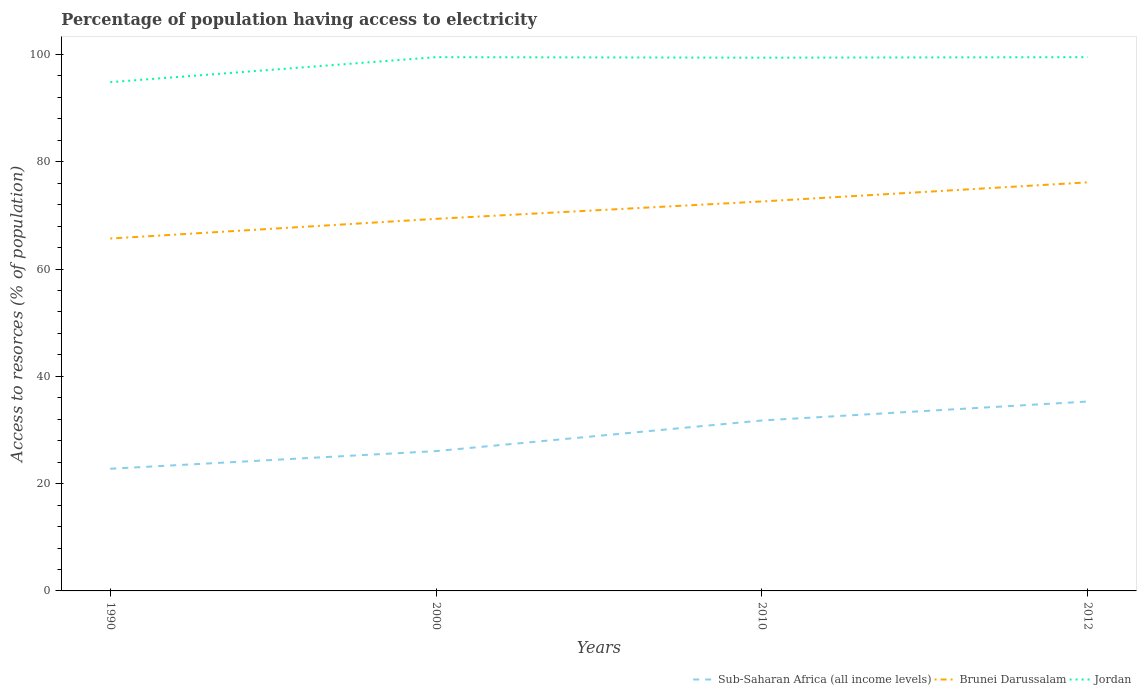Does the line corresponding to Brunei Darussalam intersect with the line corresponding to Sub-Saharan Africa (all income levels)?
Make the answer very short. No. Across all years, what is the maximum percentage of population having access to electricity in Sub-Saharan Africa (all income levels)?
Make the answer very short. 22.77. What is the total percentage of population having access to electricity in Jordan in the graph?
Offer a very short reply. -4.66. What is the difference between the highest and the second highest percentage of population having access to electricity in Brunei Darussalam?
Offer a terse response. 10.47. What is the difference between the highest and the lowest percentage of population having access to electricity in Sub-Saharan Africa (all income levels)?
Your response must be concise. 2. How many years are there in the graph?
Ensure brevity in your answer.  4. What is the difference between two consecutive major ticks on the Y-axis?
Offer a very short reply. 20. Are the values on the major ticks of Y-axis written in scientific E-notation?
Your answer should be compact. No. Does the graph contain any zero values?
Provide a succinct answer. No. Where does the legend appear in the graph?
Offer a terse response. Bottom right. How are the legend labels stacked?
Your answer should be very brief. Horizontal. What is the title of the graph?
Give a very brief answer. Percentage of population having access to electricity. Does "Afghanistan" appear as one of the legend labels in the graph?
Ensure brevity in your answer.  No. What is the label or title of the X-axis?
Your answer should be compact. Years. What is the label or title of the Y-axis?
Keep it short and to the point. Access to resorces (% of population). What is the Access to resorces (% of population) in Sub-Saharan Africa (all income levels) in 1990?
Offer a terse response. 22.77. What is the Access to resorces (% of population) of Brunei Darussalam in 1990?
Offer a terse response. 65.69. What is the Access to resorces (% of population) in Jordan in 1990?
Provide a succinct answer. 94.84. What is the Access to resorces (% of population) in Sub-Saharan Africa (all income levels) in 2000?
Make the answer very short. 26.06. What is the Access to resorces (% of population) in Brunei Darussalam in 2000?
Offer a very short reply. 69.36. What is the Access to resorces (% of population) in Jordan in 2000?
Your answer should be very brief. 99.5. What is the Access to resorces (% of population) in Sub-Saharan Africa (all income levels) in 2010?
Offer a terse response. 31.77. What is the Access to resorces (% of population) in Brunei Darussalam in 2010?
Make the answer very short. 72.6. What is the Access to resorces (% of population) of Jordan in 2010?
Make the answer very short. 99.4. What is the Access to resorces (% of population) in Sub-Saharan Africa (all income levels) in 2012?
Provide a succinct answer. 35.31. What is the Access to resorces (% of population) in Brunei Darussalam in 2012?
Offer a very short reply. 76.16. What is the Access to resorces (% of population) in Jordan in 2012?
Offer a terse response. 99.5. Across all years, what is the maximum Access to resorces (% of population) in Sub-Saharan Africa (all income levels)?
Offer a very short reply. 35.31. Across all years, what is the maximum Access to resorces (% of population) of Brunei Darussalam?
Provide a short and direct response. 76.16. Across all years, what is the maximum Access to resorces (% of population) of Jordan?
Make the answer very short. 99.5. Across all years, what is the minimum Access to resorces (% of population) of Sub-Saharan Africa (all income levels)?
Provide a short and direct response. 22.77. Across all years, what is the minimum Access to resorces (% of population) of Brunei Darussalam?
Your answer should be very brief. 65.69. Across all years, what is the minimum Access to resorces (% of population) of Jordan?
Ensure brevity in your answer.  94.84. What is the total Access to resorces (% of population) in Sub-Saharan Africa (all income levels) in the graph?
Provide a succinct answer. 115.92. What is the total Access to resorces (% of population) of Brunei Darussalam in the graph?
Your response must be concise. 283.82. What is the total Access to resorces (% of population) in Jordan in the graph?
Your answer should be very brief. 393.24. What is the difference between the Access to resorces (% of population) in Sub-Saharan Africa (all income levels) in 1990 and that in 2000?
Provide a succinct answer. -3.29. What is the difference between the Access to resorces (% of population) of Brunei Darussalam in 1990 and that in 2000?
Your response must be concise. -3.67. What is the difference between the Access to resorces (% of population) in Jordan in 1990 and that in 2000?
Keep it short and to the point. -4.66. What is the difference between the Access to resorces (% of population) of Sub-Saharan Africa (all income levels) in 1990 and that in 2010?
Your response must be concise. -9. What is the difference between the Access to resorces (% of population) of Brunei Darussalam in 1990 and that in 2010?
Ensure brevity in your answer.  -6.91. What is the difference between the Access to resorces (% of population) in Jordan in 1990 and that in 2010?
Provide a succinct answer. -4.56. What is the difference between the Access to resorces (% of population) in Sub-Saharan Africa (all income levels) in 1990 and that in 2012?
Your answer should be very brief. -12.53. What is the difference between the Access to resorces (% of population) of Brunei Darussalam in 1990 and that in 2012?
Your answer should be very brief. -10.47. What is the difference between the Access to resorces (% of population) of Jordan in 1990 and that in 2012?
Your response must be concise. -4.66. What is the difference between the Access to resorces (% of population) of Sub-Saharan Africa (all income levels) in 2000 and that in 2010?
Keep it short and to the point. -5.71. What is the difference between the Access to resorces (% of population) of Brunei Darussalam in 2000 and that in 2010?
Provide a short and direct response. -3.24. What is the difference between the Access to resorces (% of population) in Jordan in 2000 and that in 2010?
Offer a very short reply. 0.1. What is the difference between the Access to resorces (% of population) of Sub-Saharan Africa (all income levels) in 2000 and that in 2012?
Ensure brevity in your answer.  -9.24. What is the difference between the Access to resorces (% of population) of Brunei Darussalam in 2000 and that in 2012?
Your response must be concise. -6.8. What is the difference between the Access to resorces (% of population) of Sub-Saharan Africa (all income levels) in 2010 and that in 2012?
Provide a short and direct response. -3.53. What is the difference between the Access to resorces (% of population) in Brunei Darussalam in 2010 and that in 2012?
Keep it short and to the point. -3.56. What is the difference between the Access to resorces (% of population) in Jordan in 2010 and that in 2012?
Offer a very short reply. -0.1. What is the difference between the Access to resorces (% of population) of Sub-Saharan Africa (all income levels) in 1990 and the Access to resorces (% of population) of Brunei Darussalam in 2000?
Keep it short and to the point. -46.59. What is the difference between the Access to resorces (% of population) in Sub-Saharan Africa (all income levels) in 1990 and the Access to resorces (% of population) in Jordan in 2000?
Your response must be concise. -76.73. What is the difference between the Access to resorces (% of population) of Brunei Darussalam in 1990 and the Access to resorces (% of population) of Jordan in 2000?
Provide a succinct answer. -33.81. What is the difference between the Access to resorces (% of population) in Sub-Saharan Africa (all income levels) in 1990 and the Access to resorces (% of population) in Brunei Darussalam in 2010?
Give a very brief answer. -49.83. What is the difference between the Access to resorces (% of population) of Sub-Saharan Africa (all income levels) in 1990 and the Access to resorces (% of population) of Jordan in 2010?
Your response must be concise. -76.63. What is the difference between the Access to resorces (% of population) of Brunei Darussalam in 1990 and the Access to resorces (% of population) of Jordan in 2010?
Your answer should be very brief. -33.71. What is the difference between the Access to resorces (% of population) in Sub-Saharan Africa (all income levels) in 1990 and the Access to resorces (% of population) in Brunei Darussalam in 2012?
Keep it short and to the point. -53.39. What is the difference between the Access to resorces (% of population) in Sub-Saharan Africa (all income levels) in 1990 and the Access to resorces (% of population) in Jordan in 2012?
Give a very brief answer. -76.73. What is the difference between the Access to resorces (% of population) of Brunei Darussalam in 1990 and the Access to resorces (% of population) of Jordan in 2012?
Your answer should be compact. -33.81. What is the difference between the Access to resorces (% of population) of Sub-Saharan Africa (all income levels) in 2000 and the Access to resorces (% of population) of Brunei Darussalam in 2010?
Provide a short and direct response. -46.54. What is the difference between the Access to resorces (% of population) of Sub-Saharan Africa (all income levels) in 2000 and the Access to resorces (% of population) of Jordan in 2010?
Keep it short and to the point. -73.34. What is the difference between the Access to resorces (% of population) in Brunei Darussalam in 2000 and the Access to resorces (% of population) in Jordan in 2010?
Make the answer very short. -30.04. What is the difference between the Access to resorces (% of population) in Sub-Saharan Africa (all income levels) in 2000 and the Access to resorces (% of population) in Brunei Darussalam in 2012?
Your answer should be very brief. -50.1. What is the difference between the Access to resorces (% of population) in Sub-Saharan Africa (all income levels) in 2000 and the Access to resorces (% of population) in Jordan in 2012?
Provide a succinct answer. -73.44. What is the difference between the Access to resorces (% of population) of Brunei Darussalam in 2000 and the Access to resorces (% of population) of Jordan in 2012?
Give a very brief answer. -30.14. What is the difference between the Access to resorces (% of population) in Sub-Saharan Africa (all income levels) in 2010 and the Access to resorces (% of population) in Brunei Darussalam in 2012?
Your response must be concise. -44.39. What is the difference between the Access to resorces (% of population) in Sub-Saharan Africa (all income levels) in 2010 and the Access to resorces (% of population) in Jordan in 2012?
Ensure brevity in your answer.  -67.73. What is the difference between the Access to resorces (% of population) of Brunei Darussalam in 2010 and the Access to resorces (% of population) of Jordan in 2012?
Give a very brief answer. -26.9. What is the average Access to resorces (% of population) in Sub-Saharan Africa (all income levels) per year?
Give a very brief answer. 28.98. What is the average Access to resorces (% of population) of Brunei Darussalam per year?
Make the answer very short. 70.95. What is the average Access to resorces (% of population) of Jordan per year?
Keep it short and to the point. 98.31. In the year 1990, what is the difference between the Access to resorces (% of population) in Sub-Saharan Africa (all income levels) and Access to resorces (% of population) in Brunei Darussalam?
Keep it short and to the point. -42.92. In the year 1990, what is the difference between the Access to resorces (% of population) in Sub-Saharan Africa (all income levels) and Access to resorces (% of population) in Jordan?
Keep it short and to the point. -72.07. In the year 1990, what is the difference between the Access to resorces (% of population) in Brunei Darussalam and Access to resorces (% of population) in Jordan?
Give a very brief answer. -29.15. In the year 2000, what is the difference between the Access to resorces (% of population) of Sub-Saharan Africa (all income levels) and Access to resorces (% of population) of Brunei Darussalam?
Make the answer very short. -43.3. In the year 2000, what is the difference between the Access to resorces (% of population) of Sub-Saharan Africa (all income levels) and Access to resorces (% of population) of Jordan?
Make the answer very short. -73.44. In the year 2000, what is the difference between the Access to resorces (% of population) in Brunei Darussalam and Access to resorces (% of population) in Jordan?
Offer a terse response. -30.14. In the year 2010, what is the difference between the Access to resorces (% of population) in Sub-Saharan Africa (all income levels) and Access to resorces (% of population) in Brunei Darussalam?
Your response must be concise. -40.83. In the year 2010, what is the difference between the Access to resorces (% of population) in Sub-Saharan Africa (all income levels) and Access to resorces (% of population) in Jordan?
Offer a very short reply. -67.63. In the year 2010, what is the difference between the Access to resorces (% of population) of Brunei Darussalam and Access to resorces (% of population) of Jordan?
Keep it short and to the point. -26.8. In the year 2012, what is the difference between the Access to resorces (% of population) of Sub-Saharan Africa (all income levels) and Access to resorces (% of population) of Brunei Darussalam?
Offer a terse response. -40.86. In the year 2012, what is the difference between the Access to resorces (% of population) in Sub-Saharan Africa (all income levels) and Access to resorces (% of population) in Jordan?
Provide a short and direct response. -64.19. In the year 2012, what is the difference between the Access to resorces (% of population) in Brunei Darussalam and Access to resorces (% of population) in Jordan?
Provide a short and direct response. -23.34. What is the ratio of the Access to resorces (% of population) in Sub-Saharan Africa (all income levels) in 1990 to that in 2000?
Provide a short and direct response. 0.87. What is the ratio of the Access to resorces (% of population) of Brunei Darussalam in 1990 to that in 2000?
Make the answer very short. 0.95. What is the ratio of the Access to resorces (% of population) of Jordan in 1990 to that in 2000?
Give a very brief answer. 0.95. What is the ratio of the Access to resorces (% of population) of Sub-Saharan Africa (all income levels) in 1990 to that in 2010?
Make the answer very short. 0.72. What is the ratio of the Access to resorces (% of population) in Brunei Darussalam in 1990 to that in 2010?
Offer a terse response. 0.9. What is the ratio of the Access to resorces (% of population) in Jordan in 1990 to that in 2010?
Your answer should be compact. 0.95. What is the ratio of the Access to resorces (% of population) of Sub-Saharan Africa (all income levels) in 1990 to that in 2012?
Provide a succinct answer. 0.65. What is the ratio of the Access to resorces (% of population) of Brunei Darussalam in 1990 to that in 2012?
Make the answer very short. 0.86. What is the ratio of the Access to resorces (% of population) in Jordan in 1990 to that in 2012?
Offer a terse response. 0.95. What is the ratio of the Access to resorces (% of population) in Sub-Saharan Africa (all income levels) in 2000 to that in 2010?
Your answer should be compact. 0.82. What is the ratio of the Access to resorces (% of population) in Brunei Darussalam in 2000 to that in 2010?
Provide a succinct answer. 0.96. What is the ratio of the Access to resorces (% of population) of Jordan in 2000 to that in 2010?
Make the answer very short. 1. What is the ratio of the Access to resorces (% of population) of Sub-Saharan Africa (all income levels) in 2000 to that in 2012?
Keep it short and to the point. 0.74. What is the ratio of the Access to resorces (% of population) in Brunei Darussalam in 2000 to that in 2012?
Provide a short and direct response. 0.91. What is the ratio of the Access to resorces (% of population) in Jordan in 2000 to that in 2012?
Your answer should be compact. 1. What is the ratio of the Access to resorces (% of population) in Sub-Saharan Africa (all income levels) in 2010 to that in 2012?
Give a very brief answer. 0.9. What is the ratio of the Access to resorces (% of population) in Brunei Darussalam in 2010 to that in 2012?
Keep it short and to the point. 0.95. What is the ratio of the Access to resorces (% of population) in Jordan in 2010 to that in 2012?
Your answer should be very brief. 1. What is the difference between the highest and the second highest Access to resorces (% of population) in Sub-Saharan Africa (all income levels)?
Offer a terse response. 3.53. What is the difference between the highest and the second highest Access to resorces (% of population) of Brunei Darussalam?
Offer a terse response. 3.56. What is the difference between the highest and the lowest Access to resorces (% of population) in Sub-Saharan Africa (all income levels)?
Provide a succinct answer. 12.53. What is the difference between the highest and the lowest Access to resorces (% of population) in Brunei Darussalam?
Offer a terse response. 10.47. What is the difference between the highest and the lowest Access to resorces (% of population) of Jordan?
Keep it short and to the point. 4.66. 